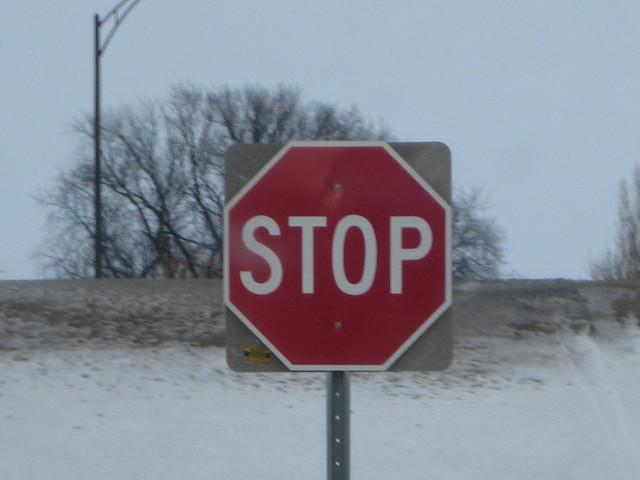What does the sign say to do?
Concise answer only. Stop. Is there snow on the ground?
Quick response, please. Yes. How many letters are on the stop sign?
Write a very short answer. 4. What season is it?
Answer briefly. Winter. What does the sign say?
Quick response, please. Stop. Is the sign in two languages?
Short answer required. No. What color is the sign?
Give a very brief answer. Red. What sign is shown?
Give a very brief answer. Stop. 